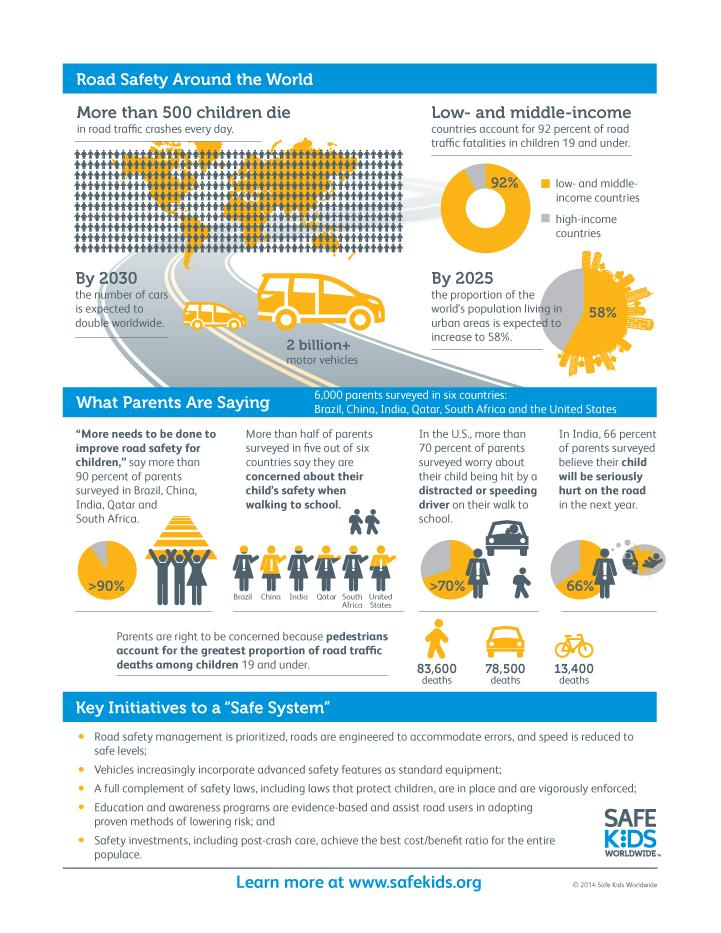Specify some key components in this picture. According to data, a total of 91,900 children have died as a result of bicycle or car accidents. According to this infographic, there are five initiatives for road safety. In high-income countries, an estimated 8% of road traffic fatalities involve children. 